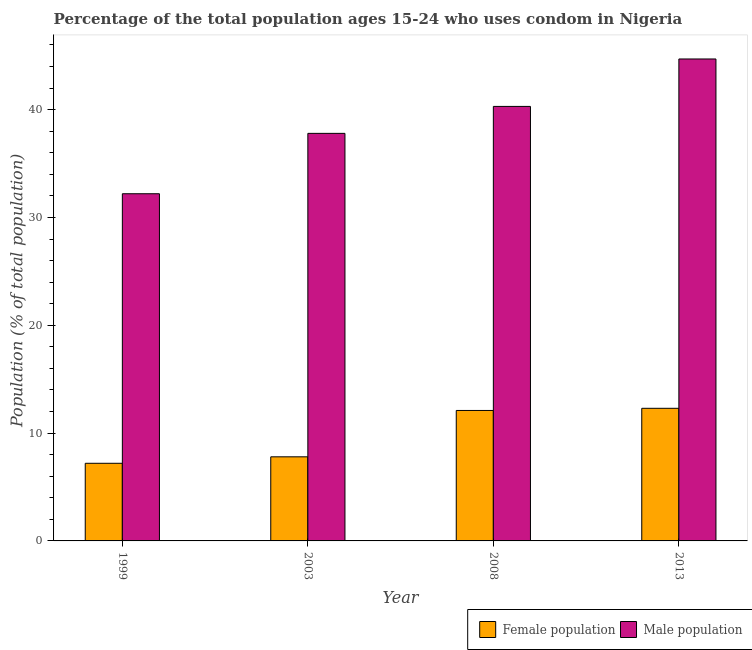How many different coloured bars are there?
Keep it short and to the point. 2. How many groups of bars are there?
Offer a terse response. 4. Are the number of bars on each tick of the X-axis equal?
Provide a succinct answer. Yes. How many bars are there on the 2nd tick from the left?
Provide a succinct answer. 2. In how many cases, is the number of bars for a given year not equal to the number of legend labels?
Your response must be concise. 0. What is the male population in 2013?
Provide a succinct answer. 44.7. Across all years, what is the maximum male population?
Offer a terse response. 44.7. Across all years, what is the minimum male population?
Offer a terse response. 32.2. What is the total male population in the graph?
Keep it short and to the point. 155. What is the difference between the female population in 1999 and that in 2003?
Your answer should be very brief. -0.6. What is the difference between the female population in 2003 and the male population in 1999?
Provide a succinct answer. 0.6. What is the average male population per year?
Offer a terse response. 38.75. In how many years, is the female population greater than 40 %?
Provide a short and direct response. 0. What is the ratio of the female population in 2003 to that in 2013?
Offer a terse response. 0.63. What is the difference between the highest and the second highest male population?
Provide a succinct answer. 4.4. What does the 1st bar from the left in 2003 represents?
Keep it short and to the point. Female population. What does the 2nd bar from the right in 2003 represents?
Offer a very short reply. Female population. Does the graph contain grids?
Provide a short and direct response. No. Where does the legend appear in the graph?
Keep it short and to the point. Bottom right. How many legend labels are there?
Your answer should be very brief. 2. How are the legend labels stacked?
Provide a succinct answer. Horizontal. What is the title of the graph?
Ensure brevity in your answer.  Percentage of the total population ages 15-24 who uses condom in Nigeria. Does "Underweight" appear as one of the legend labels in the graph?
Your response must be concise. No. What is the label or title of the X-axis?
Your answer should be very brief. Year. What is the label or title of the Y-axis?
Offer a terse response. Population (% of total population) . What is the Population (% of total population)  in Male population in 1999?
Your answer should be compact. 32.2. What is the Population (% of total population)  of Male population in 2003?
Keep it short and to the point. 37.8. What is the Population (% of total population)  in Female population in 2008?
Your answer should be compact. 12.1. What is the Population (% of total population)  of Male population in 2008?
Your response must be concise. 40.3. What is the Population (% of total population)  of Male population in 2013?
Provide a short and direct response. 44.7. Across all years, what is the maximum Population (% of total population)  of Female population?
Provide a short and direct response. 12.3. Across all years, what is the maximum Population (% of total population)  of Male population?
Your response must be concise. 44.7. Across all years, what is the minimum Population (% of total population)  of Female population?
Provide a short and direct response. 7.2. Across all years, what is the minimum Population (% of total population)  in Male population?
Make the answer very short. 32.2. What is the total Population (% of total population)  in Female population in the graph?
Your response must be concise. 39.4. What is the total Population (% of total population)  in Male population in the graph?
Provide a short and direct response. 155. What is the difference between the Population (% of total population)  of Female population in 1999 and that in 2008?
Your response must be concise. -4.9. What is the difference between the Population (% of total population)  in Male population in 1999 and that in 2013?
Offer a very short reply. -12.5. What is the difference between the Population (% of total population)  in Female population in 2003 and that in 2008?
Provide a short and direct response. -4.3. What is the difference between the Population (% of total population)  of Male population in 2003 and that in 2013?
Make the answer very short. -6.9. What is the difference between the Population (% of total population)  of Female population in 2008 and that in 2013?
Give a very brief answer. -0.2. What is the difference between the Population (% of total population)  of Female population in 1999 and the Population (% of total population)  of Male population in 2003?
Your answer should be very brief. -30.6. What is the difference between the Population (% of total population)  of Female population in 1999 and the Population (% of total population)  of Male population in 2008?
Provide a short and direct response. -33.1. What is the difference between the Population (% of total population)  of Female population in 1999 and the Population (% of total population)  of Male population in 2013?
Ensure brevity in your answer.  -37.5. What is the difference between the Population (% of total population)  of Female population in 2003 and the Population (% of total population)  of Male population in 2008?
Make the answer very short. -32.5. What is the difference between the Population (% of total population)  in Female population in 2003 and the Population (% of total population)  in Male population in 2013?
Your response must be concise. -36.9. What is the difference between the Population (% of total population)  in Female population in 2008 and the Population (% of total population)  in Male population in 2013?
Your answer should be compact. -32.6. What is the average Population (% of total population)  in Female population per year?
Keep it short and to the point. 9.85. What is the average Population (% of total population)  of Male population per year?
Give a very brief answer. 38.75. In the year 2003, what is the difference between the Population (% of total population)  in Female population and Population (% of total population)  in Male population?
Give a very brief answer. -30. In the year 2008, what is the difference between the Population (% of total population)  of Female population and Population (% of total population)  of Male population?
Make the answer very short. -28.2. In the year 2013, what is the difference between the Population (% of total population)  of Female population and Population (% of total population)  of Male population?
Your answer should be very brief. -32.4. What is the ratio of the Population (% of total population)  of Female population in 1999 to that in 2003?
Your answer should be compact. 0.92. What is the ratio of the Population (% of total population)  in Male population in 1999 to that in 2003?
Give a very brief answer. 0.85. What is the ratio of the Population (% of total population)  of Female population in 1999 to that in 2008?
Your answer should be compact. 0.59. What is the ratio of the Population (% of total population)  in Male population in 1999 to that in 2008?
Make the answer very short. 0.8. What is the ratio of the Population (% of total population)  of Female population in 1999 to that in 2013?
Provide a succinct answer. 0.59. What is the ratio of the Population (% of total population)  of Male population in 1999 to that in 2013?
Offer a terse response. 0.72. What is the ratio of the Population (% of total population)  of Female population in 2003 to that in 2008?
Give a very brief answer. 0.64. What is the ratio of the Population (% of total population)  in Male population in 2003 to that in 2008?
Your answer should be compact. 0.94. What is the ratio of the Population (% of total population)  in Female population in 2003 to that in 2013?
Your answer should be compact. 0.63. What is the ratio of the Population (% of total population)  of Male population in 2003 to that in 2013?
Make the answer very short. 0.85. What is the ratio of the Population (% of total population)  of Female population in 2008 to that in 2013?
Make the answer very short. 0.98. What is the ratio of the Population (% of total population)  in Male population in 2008 to that in 2013?
Your answer should be compact. 0.9. What is the difference between the highest and the second highest Population (% of total population)  of Female population?
Provide a short and direct response. 0.2. What is the difference between the highest and the second highest Population (% of total population)  in Male population?
Your answer should be compact. 4.4. What is the difference between the highest and the lowest Population (% of total population)  in Female population?
Provide a succinct answer. 5.1. 